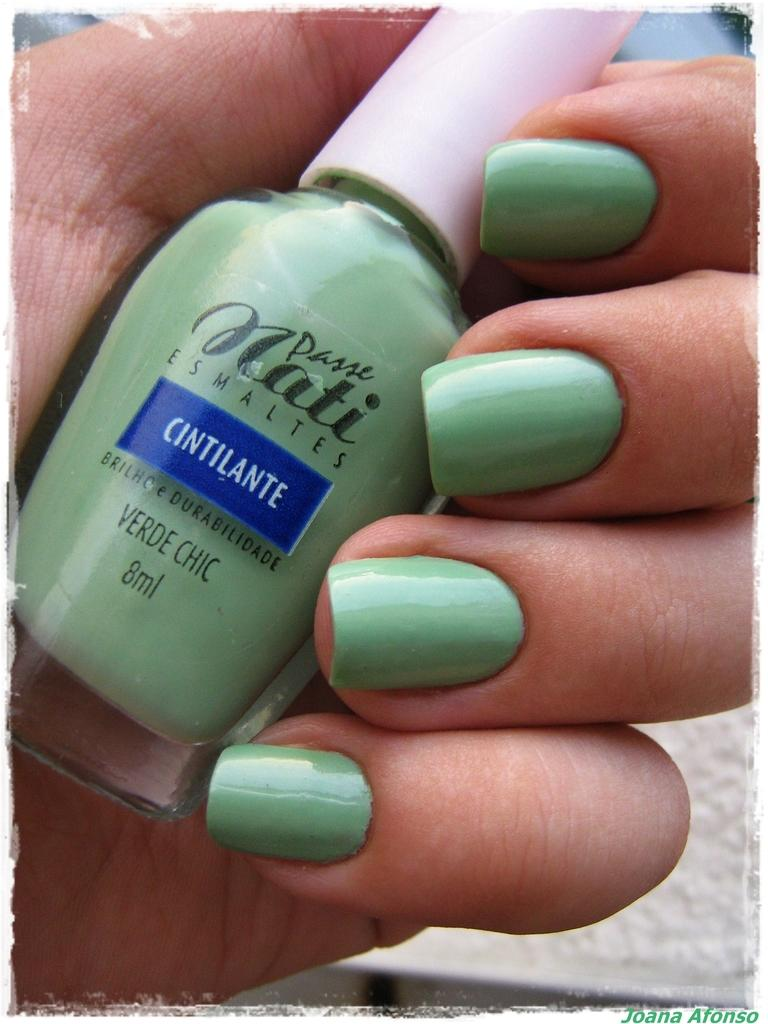What is the person's hand holding in the image? The hand is holding a nail polish bottle in the image. Can you describe the main object in the person's hand? The main object in the person's hand is a nail polish bottle. What is visible at the bottom of the image? There is text at the bottom of the image. What type of ornament is hanging on the side of the person in the image? There is no ornament visible in the image. How does the person in the image show respect to the nail polish bottle? The image does not show any indication of respect towards the nail polish bottle. 